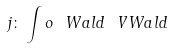Convert formula to latex. <formula><loc_0><loc_0><loc_500><loc_500>j \colon \int o { \ W a l d } { \ V W a l d }</formula> 